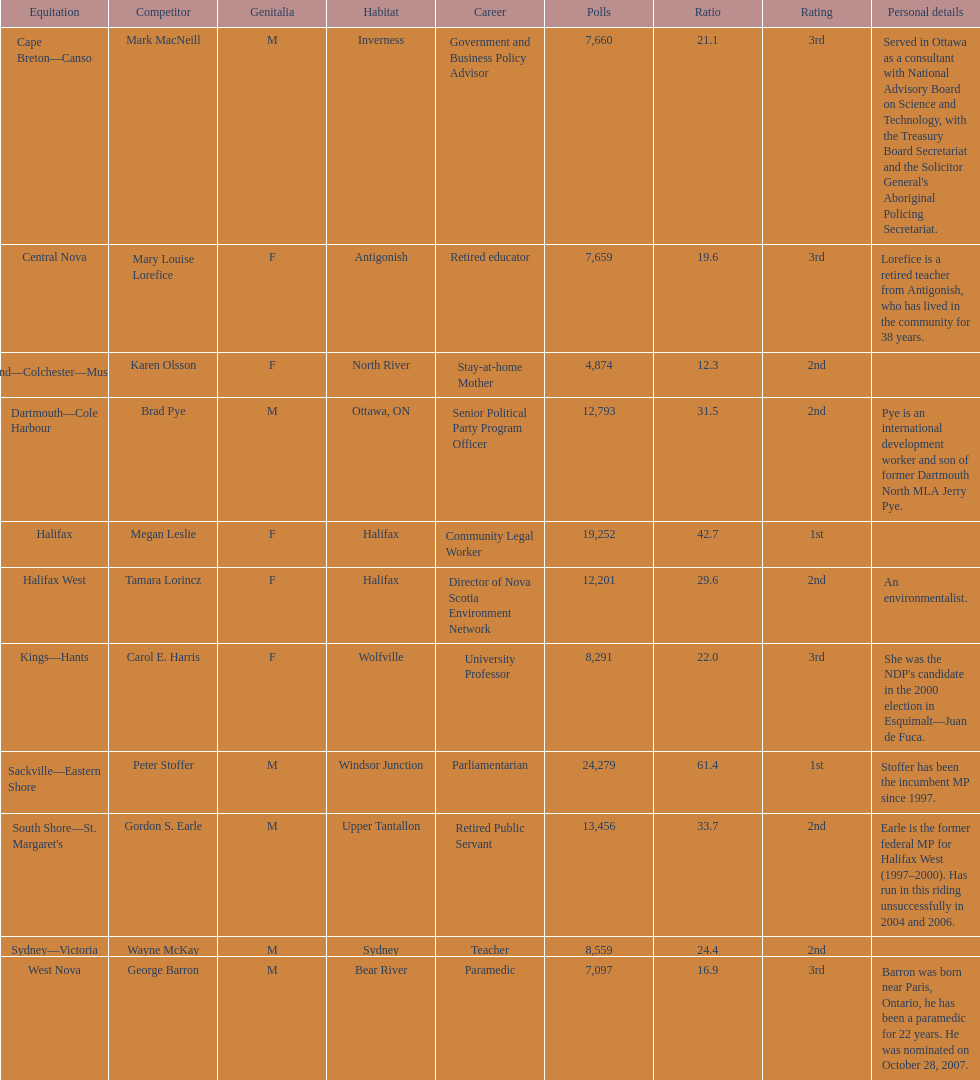What is the number of votes that megan leslie received? 19,252. 